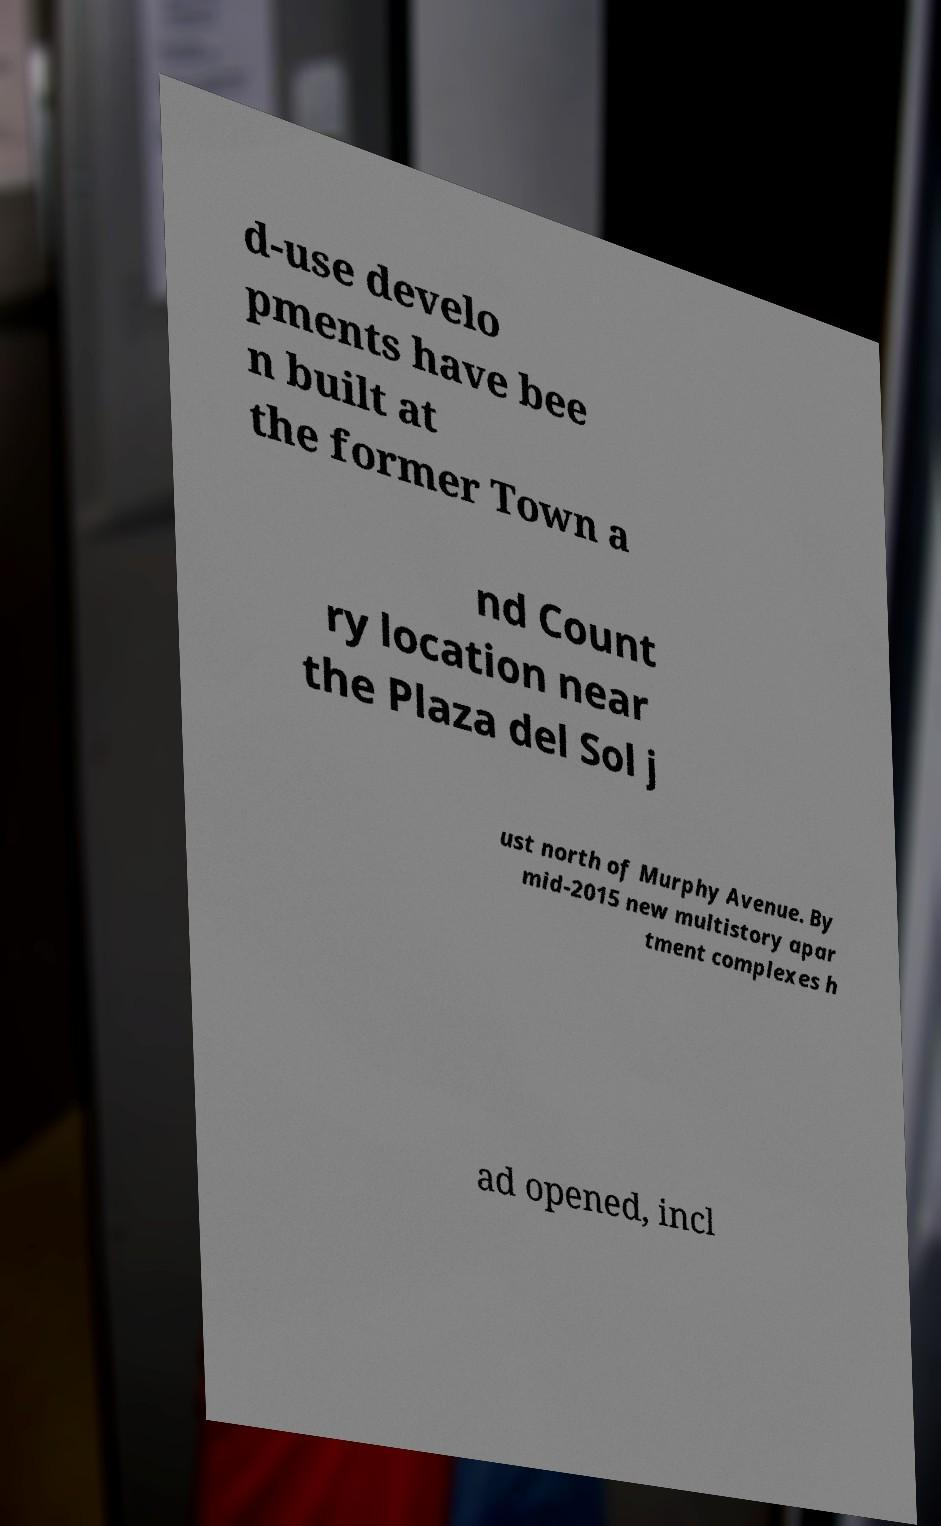Can you read and provide the text displayed in the image?This photo seems to have some interesting text. Can you extract and type it out for me? d-use develo pments have bee n built at the former Town a nd Count ry location near the Plaza del Sol j ust north of Murphy Avenue. By mid-2015 new multistory apar tment complexes h ad opened, incl 